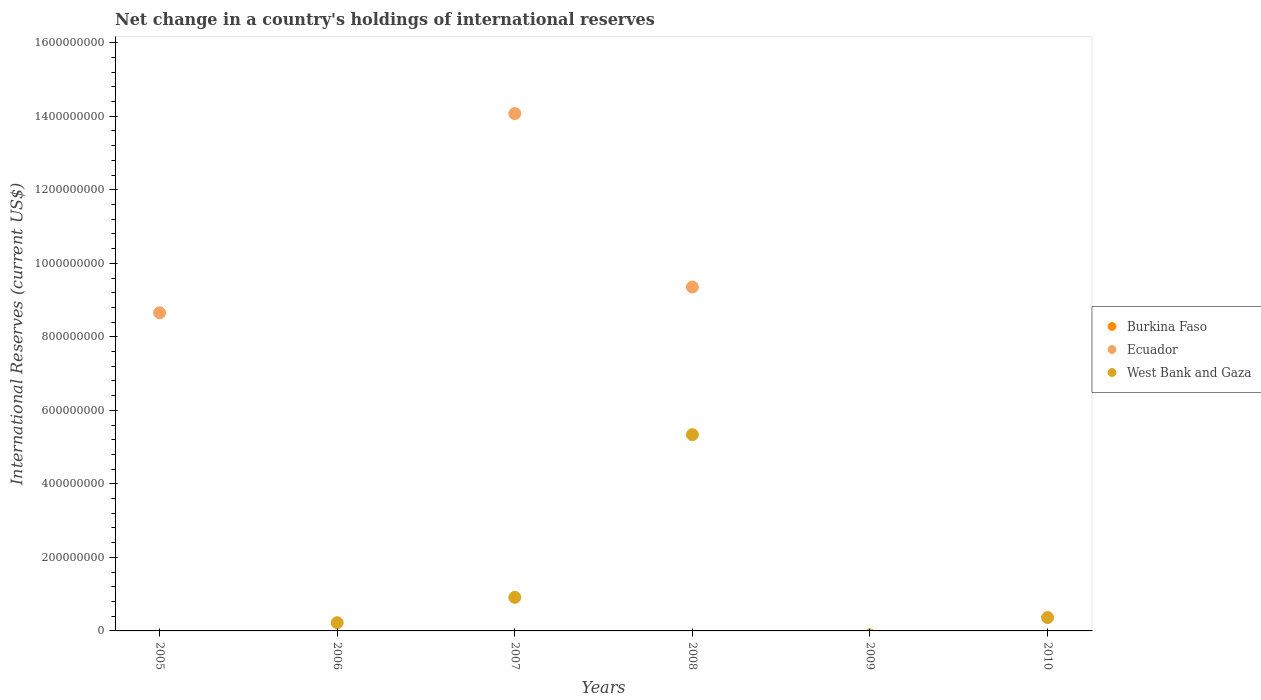Across all years, what is the maximum international reserves in West Bank and Gaza?
Keep it short and to the point. 5.34e+08. Across all years, what is the minimum international reserves in Burkina Faso?
Your answer should be very brief. 0. What is the total international reserves in Ecuador in the graph?
Offer a very short reply. 3.21e+09. What is the difference between the international reserves in Ecuador in 2005 and that in 2007?
Offer a terse response. -5.42e+08. What is the average international reserves in West Bank and Gaza per year?
Provide a short and direct response. 1.14e+08. In the year 2008, what is the difference between the international reserves in Ecuador and international reserves in West Bank and Gaza?
Ensure brevity in your answer.  4.02e+08. In how many years, is the international reserves in Burkina Faso greater than 560000000 US$?
Your answer should be compact. 0. What is the ratio of the international reserves in West Bank and Gaza in 2007 to that in 2008?
Provide a succinct answer. 0.17. What is the difference between the highest and the second highest international reserves in West Bank and Gaza?
Provide a succinct answer. 4.43e+08. What is the difference between the highest and the lowest international reserves in West Bank and Gaza?
Make the answer very short. 5.34e+08. In how many years, is the international reserves in Ecuador greater than the average international reserves in Ecuador taken over all years?
Your answer should be very brief. 3. Is it the case that in every year, the sum of the international reserves in West Bank and Gaza and international reserves in Burkina Faso  is greater than the international reserves in Ecuador?
Offer a terse response. No. Does the international reserves in Ecuador monotonically increase over the years?
Give a very brief answer. No. Is the international reserves in Burkina Faso strictly less than the international reserves in West Bank and Gaza over the years?
Your answer should be very brief. Yes. How many dotlines are there?
Make the answer very short. 2. What is the difference between two consecutive major ticks on the Y-axis?
Your answer should be very brief. 2.00e+08. Does the graph contain grids?
Offer a very short reply. No. What is the title of the graph?
Make the answer very short. Net change in a country's holdings of international reserves. What is the label or title of the Y-axis?
Provide a short and direct response. International Reserves (current US$). What is the International Reserves (current US$) of Ecuador in 2005?
Offer a terse response. 8.65e+08. What is the International Reserves (current US$) of West Bank and Gaza in 2005?
Ensure brevity in your answer.  0. What is the International Reserves (current US$) in West Bank and Gaza in 2006?
Offer a terse response. 2.23e+07. What is the International Reserves (current US$) in Ecuador in 2007?
Give a very brief answer. 1.41e+09. What is the International Reserves (current US$) in West Bank and Gaza in 2007?
Your response must be concise. 9.13e+07. What is the International Reserves (current US$) of Ecuador in 2008?
Make the answer very short. 9.35e+08. What is the International Reserves (current US$) of West Bank and Gaza in 2008?
Your answer should be very brief. 5.34e+08. What is the International Reserves (current US$) in Burkina Faso in 2009?
Your answer should be compact. 0. What is the International Reserves (current US$) in Ecuador in 2009?
Your answer should be very brief. 0. What is the International Reserves (current US$) in West Bank and Gaza in 2009?
Ensure brevity in your answer.  0. What is the International Reserves (current US$) in Ecuador in 2010?
Give a very brief answer. 0. What is the International Reserves (current US$) in West Bank and Gaza in 2010?
Keep it short and to the point. 3.64e+07. Across all years, what is the maximum International Reserves (current US$) of Ecuador?
Ensure brevity in your answer.  1.41e+09. Across all years, what is the maximum International Reserves (current US$) of West Bank and Gaza?
Keep it short and to the point. 5.34e+08. Across all years, what is the minimum International Reserves (current US$) of West Bank and Gaza?
Provide a short and direct response. 0. What is the total International Reserves (current US$) of Ecuador in the graph?
Offer a terse response. 3.21e+09. What is the total International Reserves (current US$) in West Bank and Gaza in the graph?
Ensure brevity in your answer.  6.84e+08. What is the difference between the International Reserves (current US$) in Ecuador in 2005 and that in 2007?
Offer a very short reply. -5.42e+08. What is the difference between the International Reserves (current US$) of Ecuador in 2005 and that in 2008?
Offer a terse response. -7.00e+07. What is the difference between the International Reserves (current US$) of West Bank and Gaza in 2006 and that in 2007?
Offer a terse response. -6.90e+07. What is the difference between the International Reserves (current US$) of West Bank and Gaza in 2006 and that in 2008?
Keep it short and to the point. -5.11e+08. What is the difference between the International Reserves (current US$) of West Bank and Gaza in 2006 and that in 2010?
Provide a short and direct response. -1.41e+07. What is the difference between the International Reserves (current US$) of Ecuador in 2007 and that in 2008?
Your answer should be compact. 4.72e+08. What is the difference between the International Reserves (current US$) in West Bank and Gaza in 2007 and that in 2008?
Provide a succinct answer. -4.43e+08. What is the difference between the International Reserves (current US$) of West Bank and Gaza in 2007 and that in 2010?
Your response must be concise. 5.49e+07. What is the difference between the International Reserves (current US$) in West Bank and Gaza in 2008 and that in 2010?
Your answer should be very brief. 4.97e+08. What is the difference between the International Reserves (current US$) of Ecuador in 2005 and the International Reserves (current US$) of West Bank and Gaza in 2006?
Provide a succinct answer. 8.43e+08. What is the difference between the International Reserves (current US$) of Ecuador in 2005 and the International Reserves (current US$) of West Bank and Gaza in 2007?
Give a very brief answer. 7.74e+08. What is the difference between the International Reserves (current US$) in Ecuador in 2005 and the International Reserves (current US$) in West Bank and Gaza in 2008?
Provide a succinct answer. 3.32e+08. What is the difference between the International Reserves (current US$) of Ecuador in 2005 and the International Reserves (current US$) of West Bank and Gaza in 2010?
Your response must be concise. 8.29e+08. What is the difference between the International Reserves (current US$) of Ecuador in 2007 and the International Reserves (current US$) of West Bank and Gaza in 2008?
Offer a terse response. 8.73e+08. What is the difference between the International Reserves (current US$) of Ecuador in 2007 and the International Reserves (current US$) of West Bank and Gaza in 2010?
Make the answer very short. 1.37e+09. What is the difference between the International Reserves (current US$) of Ecuador in 2008 and the International Reserves (current US$) of West Bank and Gaza in 2010?
Provide a short and direct response. 8.99e+08. What is the average International Reserves (current US$) in Ecuador per year?
Give a very brief answer. 5.35e+08. What is the average International Reserves (current US$) in West Bank and Gaza per year?
Your answer should be very brief. 1.14e+08. In the year 2007, what is the difference between the International Reserves (current US$) in Ecuador and International Reserves (current US$) in West Bank and Gaza?
Provide a succinct answer. 1.32e+09. In the year 2008, what is the difference between the International Reserves (current US$) of Ecuador and International Reserves (current US$) of West Bank and Gaza?
Provide a short and direct response. 4.02e+08. What is the ratio of the International Reserves (current US$) of Ecuador in 2005 to that in 2007?
Give a very brief answer. 0.61. What is the ratio of the International Reserves (current US$) of Ecuador in 2005 to that in 2008?
Provide a succinct answer. 0.93. What is the ratio of the International Reserves (current US$) in West Bank and Gaza in 2006 to that in 2007?
Provide a succinct answer. 0.24. What is the ratio of the International Reserves (current US$) in West Bank and Gaza in 2006 to that in 2008?
Provide a short and direct response. 0.04. What is the ratio of the International Reserves (current US$) in West Bank and Gaza in 2006 to that in 2010?
Provide a succinct answer. 0.61. What is the ratio of the International Reserves (current US$) of Ecuador in 2007 to that in 2008?
Your response must be concise. 1.5. What is the ratio of the International Reserves (current US$) in West Bank and Gaza in 2007 to that in 2008?
Keep it short and to the point. 0.17. What is the ratio of the International Reserves (current US$) in West Bank and Gaza in 2007 to that in 2010?
Make the answer very short. 2.51. What is the ratio of the International Reserves (current US$) in West Bank and Gaza in 2008 to that in 2010?
Provide a succinct answer. 14.66. What is the difference between the highest and the second highest International Reserves (current US$) in Ecuador?
Provide a succinct answer. 4.72e+08. What is the difference between the highest and the second highest International Reserves (current US$) in West Bank and Gaza?
Your answer should be very brief. 4.43e+08. What is the difference between the highest and the lowest International Reserves (current US$) in Ecuador?
Provide a short and direct response. 1.41e+09. What is the difference between the highest and the lowest International Reserves (current US$) of West Bank and Gaza?
Your answer should be compact. 5.34e+08. 